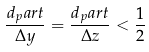Convert formula to latex. <formula><loc_0><loc_0><loc_500><loc_500>\frac { d _ { p } a r t } { \Delta y } = \frac { d _ { p } a r t } { \Delta z } < \frac { 1 } { 2 }</formula> 